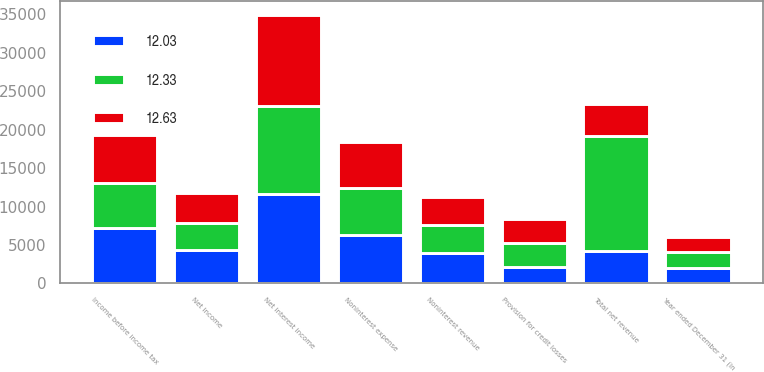Convert chart to OTSL. <chart><loc_0><loc_0><loc_500><loc_500><stacked_bar_chart><ecel><fcel>Year ended December 31 (in<fcel>Noninterest revenue<fcel>Net interest income<fcel>Total net revenue<fcel>Provision for credit losses<fcel>Noninterest expense<fcel>Income before income tax<fcel>Net income<nl><fcel>12.63<fcel>2015<fcel>3673<fcel>11845<fcel>4158.5<fcel>3122<fcel>6065<fcel>6331<fcel>3930<nl><fcel>12.33<fcel>2014<fcel>3593<fcel>11462<fcel>15055<fcel>3079<fcel>6152<fcel>5824<fcel>3547<nl><fcel>12.03<fcel>2013<fcel>3977<fcel>11638<fcel>4158.5<fcel>2179<fcel>6245<fcel>7191<fcel>4340<nl></chart> 